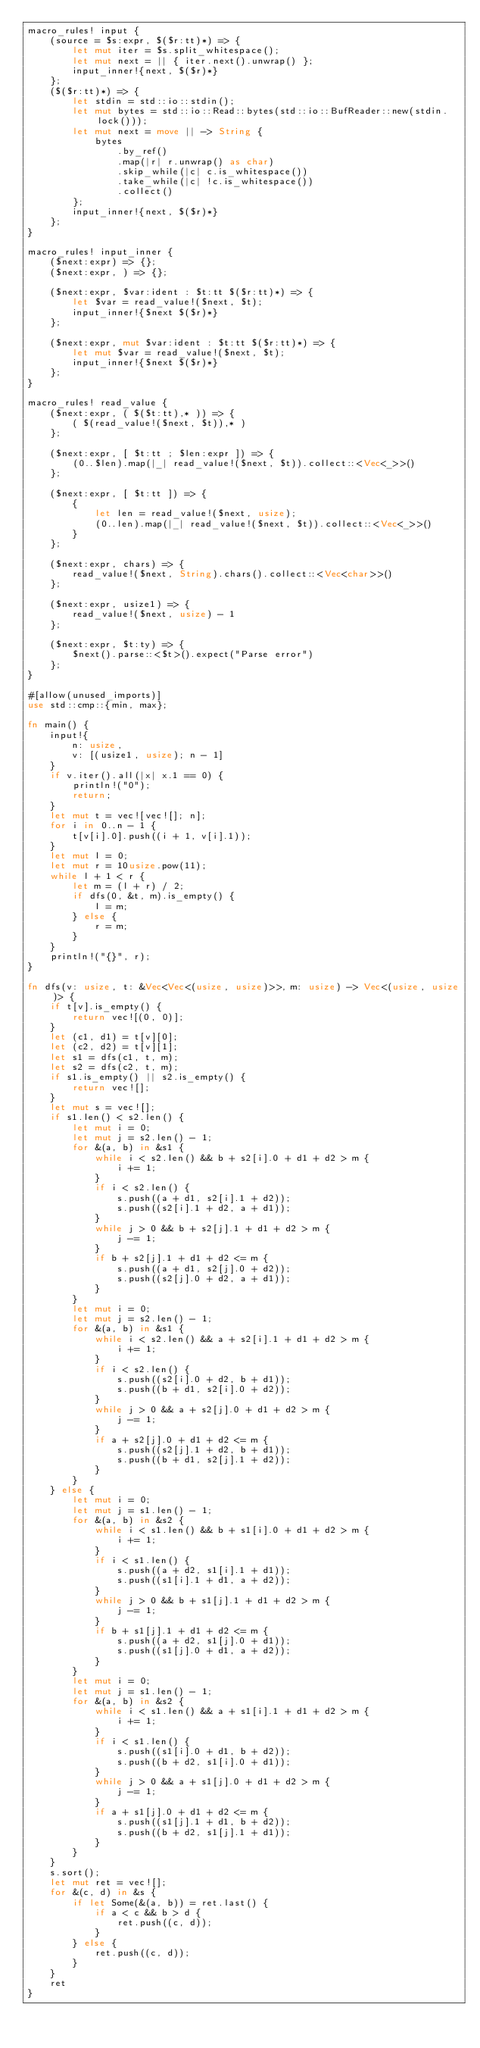Convert code to text. <code><loc_0><loc_0><loc_500><loc_500><_Rust_>macro_rules! input {
    (source = $s:expr, $($r:tt)*) => {
        let mut iter = $s.split_whitespace();
        let mut next = || { iter.next().unwrap() };
        input_inner!{next, $($r)*}
    };
    ($($r:tt)*) => {
        let stdin = std::io::stdin();
        let mut bytes = std::io::Read::bytes(std::io::BufReader::new(stdin.lock()));
        let mut next = move || -> String {
            bytes
                .by_ref()
                .map(|r| r.unwrap() as char)
                .skip_while(|c| c.is_whitespace())
                .take_while(|c| !c.is_whitespace())
                .collect()
        };
        input_inner!{next, $($r)*}
    };
}

macro_rules! input_inner {
    ($next:expr) => {};
    ($next:expr, ) => {};

    ($next:expr, $var:ident : $t:tt $($r:tt)*) => {
        let $var = read_value!($next, $t);
        input_inner!{$next $($r)*}
    };

    ($next:expr, mut $var:ident : $t:tt $($r:tt)*) => {
        let mut $var = read_value!($next, $t);
        input_inner!{$next $($r)*}
    };
}

macro_rules! read_value {
    ($next:expr, ( $($t:tt),* )) => {
        ( $(read_value!($next, $t)),* )
    };

    ($next:expr, [ $t:tt ; $len:expr ]) => {
        (0..$len).map(|_| read_value!($next, $t)).collect::<Vec<_>>()
    };

    ($next:expr, [ $t:tt ]) => {
        {
            let len = read_value!($next, usize);
            (0..len).map(|_| read_value!($next, $t)).collect::<Vec<_>>()
        }
    };

    ($next:expr, chars) => {
        read_value!($next, String).chars().collect::<Vec<char>>()
    };

    ($next:expr, usize1) => {
        read_value!($next, usize) - 1
    };

    ($next:expr, $t:ty) => {
        $next().parse::<$t>().expect("Parse error")
    };
}

#[allow(unused_imports)]
use std::cmp::{min, max};

fn main() {
    input!{
        n: usize,
        v: [(usize1, usize); n - 1]
    }
    if v.iter().all(|x| x.1 == 0) {
        println!("0");
        return;
    }
    let mut t = vec![vec![]; n];
    for i in 0..n - 1 {
        t[v[i].0].push((i + 1, v[i].1));
    }
    let mut l = 0;
    let mut r = 10usize.pow(11);
    while l + 1 < r {
        let m = (l + r) / 2;
        if dfs(0, &t, m).is_empty() {
            l = m;
        } else {
            r = m;
        }
    }
    println!("{}", r);
}

fn dfs(v: usize, t: &Vec<Vec<(usize, usize)>>, m: usize) -> Vec<(usize, usize)> {
    if t[v].is_empty() {
        return vec![(0, 0)];
    }
    let (c1, d1) = t[v][0];
    let (c2, d2) = t[v][1];
    let s1 = dfs(c1, t, m);
    let s2 = dfs(c2, t, m);
    if s1.is_empty() || s2.is_empty() {
        return vec![];
    }
    let mut s = vec![];
    if s1.len() < s2.len() {
        let mut i = 0;
        let mut j = s2.len() - 1;
        for &(a, b) in &s1 {
            while i < s2.len() && b + s2[i].0 + d1 + d2 > m {
                i += 1;
            }
            if i < s2.len() {
                s.push((a + d1, s2[i].1 + d2));
                s.push((s2[i].1 + d2, a + d1));
            }
            while j > 0 && b + s2[j].1 + d1 + d2 > m {
                j -= 1;
            }
            if b + s2[j].1 + d1 + d2 <= m {
                s.push((a + d1, s2[j].0 + d2));
                s.push((s2[j].0 + d2, a + d1));
            }
        }
        let mut i = 0;
        let mut j = s2.len() - 1;
        for &(a, b) in &s1 {
            while i < s2.len() && a + s2[i].1 + d1 + d2 > m {
                i += 1;
            }
            if i < s2.len() {
                s.push((s2[i].0 + d2, b + d1));
                s.push((b + d1, s2[i].0 + d2));
            }
            while j > 0 && a + s2[j].0 + d1 + d2 > m {
                j -= 1;
            }
            if a + s2[j].0 + d1 + d2 <= m {
                s.push((s2[j].1 + d2, b + d1));
                s.push((b + d1, s2[j].1 + d2));
            }
        }
    } else {
        let mut i = 0;
        let mut j = s1.len() - 1;
        for &(a, b) in &s2 {
            while i < s1.len() && b + s1[i].0 + d1 + d2 > m {
                i += 1;
            }
            if i < s1.len() {
                s.push((a + d2, s1[i].1 + d1));
                s.push((s1[i].1 + d1, a + d2));
            }
            while j > 0 && b + s1[j].1 + d1 + d2 > m {
                j -= 1;
            }
            if b + s1[j].1 + d1 + d2 <= m {
                s.push((a + d2, s1[j].0 + d1));
                s.push((s1[j].0 + d1, a + d2));
            }
        }
        let mut i = 0;
        let mut j = s1.len() - 1;
        for &(a, b) in &s2 {
            while i < s1.len() && a + s1[i].1 + d1 + d2 > m {
                i += 1;
            }
            if i < s1.len() {
                s.push((s1[i].0 + d1, b + d2));
                s.push((b + d2, s1[i].0 + d1));
            }
            while j > 0 && a + s1[j].0 + d1 + d2 > m {
                j -= 1;
            }
            if a + s1[j].0 + d1 + d2 <= m {
                s.push((s1[j].1 + d1, b + d2));
                s.push((b + d2, s1[j].1 + d1));
            }
        }
    }
    s.sort();
    let mut ret = vec![];
    for &(c, d) in &s {
        if let Some(&(a, b)) = ret.last() {
            if a < c && b > d {
                ret.push((c, d));
            }
        } else {
            ret.push((c, d));
        }
    }
    ret
}
</code> 